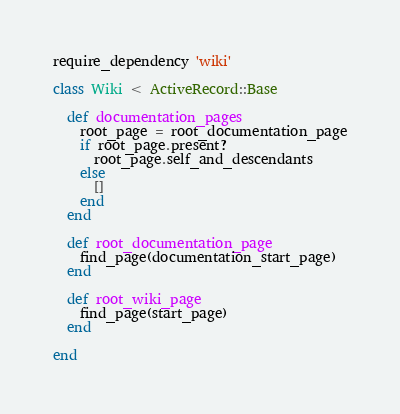Convert code to text. <code><loc_0><loc_0><loc_500><loc_500><_Ruby_>require_dependency 'wiki'

class Wiki < ActiveRecord::Base

  def documentation_pages
    root_page = root_documentation_page
    if root_page.present?
      root_page.self_and_descendants
    else
      []
    end
  end

  def root_documentation_page
    find_page(documentation_start_page)
  end

  def root_wiki_page
    find_page(start_page)
  end

end
</code> 